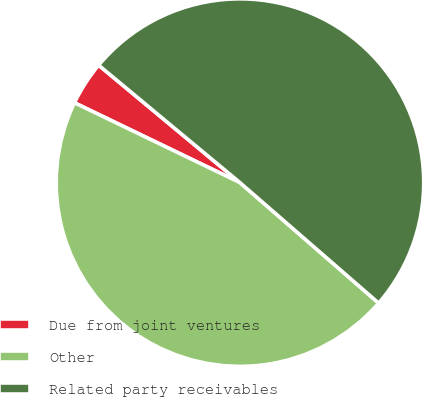Convert chart. <chart><loc_0><loc_0><loc_500><loc_500><pie_chart><fcel>Due from joint ventures<fcel>Other<fcel>Related party receivables<nl><fcel>3.88%<fcel>45.77%<fcel>50.35%<nl></chart> 